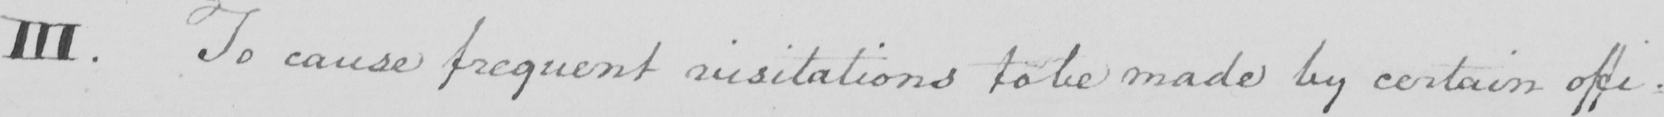What text is written in this handwritten line? III. To cause frequent visitations to be made by certain offi: 